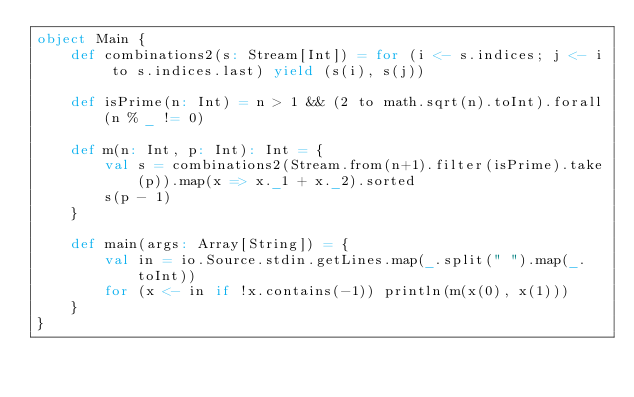<code> <loc_0><loc_0><loc_500><loc_500><_Scala_>object Main {
    def combinations2(s: Stream[Int]) = for (i <- s.indices; j <- i to s.indices.last) yield (s(i), s(j))
            
    def isPrime(n: Int) = n > 1 && (2 to math.sqrt(n).toInt).forall(n % _ != 0)

    def m(n: Int, p: Int): Int = {
        val s = combinations2(Stream.from(n+1).filter(isPrime).take(p)).map(x => x._1 + x._2).sorted
        s(p - 1)
    }

    def main(args: Array[String]) = {
        val in = io.Source.stdin.getLines.map(_.split(" ").map(_.toInt))
        for (x <- in if !x.contains(-1)) println(m(x(0), x(1)))
    }
}</code> 